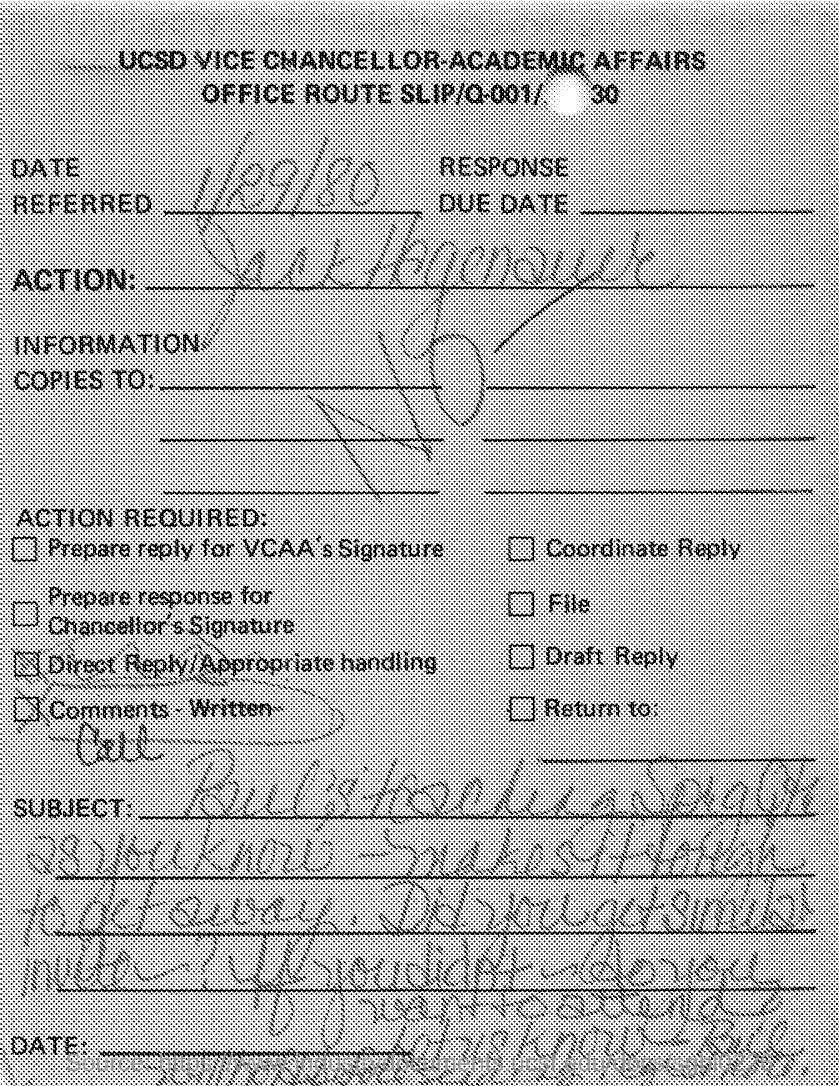List a handful of essential elements in this visual. The date referred to in the document is January 29, 1980. 